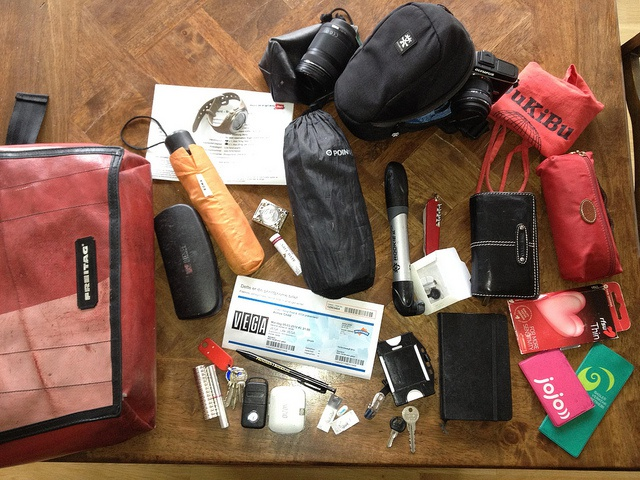Describe the objects in this image and their specific colors. I can see backpack in gray, brown, salmon, black, and maroon tones, handbag in gray, salmon, maroon, and brown tones, handbag in gray, brown, maroon, and salmon tones, umbrella in gray, orange, tan, red, and white tones, and cell phone in gray, black, and white tones in this image. 